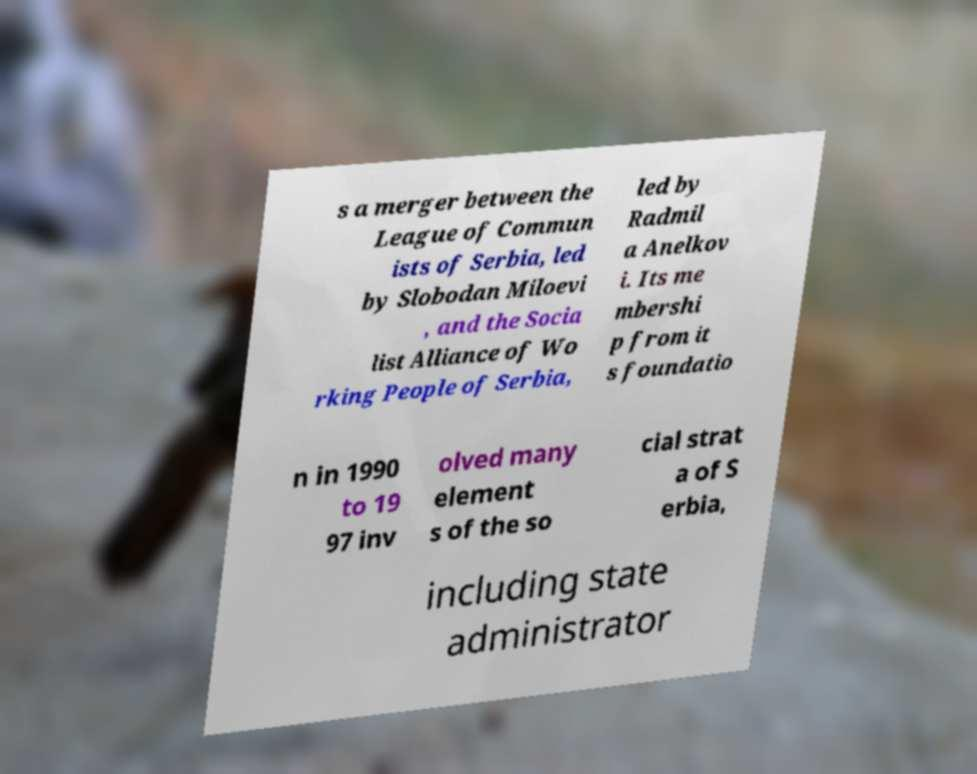I need the written content from this picture converted into text. Can you do that? s a merger between the League of Commun ists of Serbia, led by Slobodan Miloevi , and the Socia list Alliance of Wo rking People of Serbia, led by Radmil a Anelkov i. Its me mbershi p from it s foundatio n in 1990 to 19 97 inv olved many element s of the so cial strat a of S erbia, including state administrator 